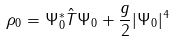<formula> <loc_0><loc_0><loc_500><loc_500>\rho _ { 0 } = \Psi _ { 0 } ^ { \ast } \hat { T } \Psi _ { 0 } + \frac { g } { 2 } | \Psi _ { 0 } | ^ { 4 }</formula> 